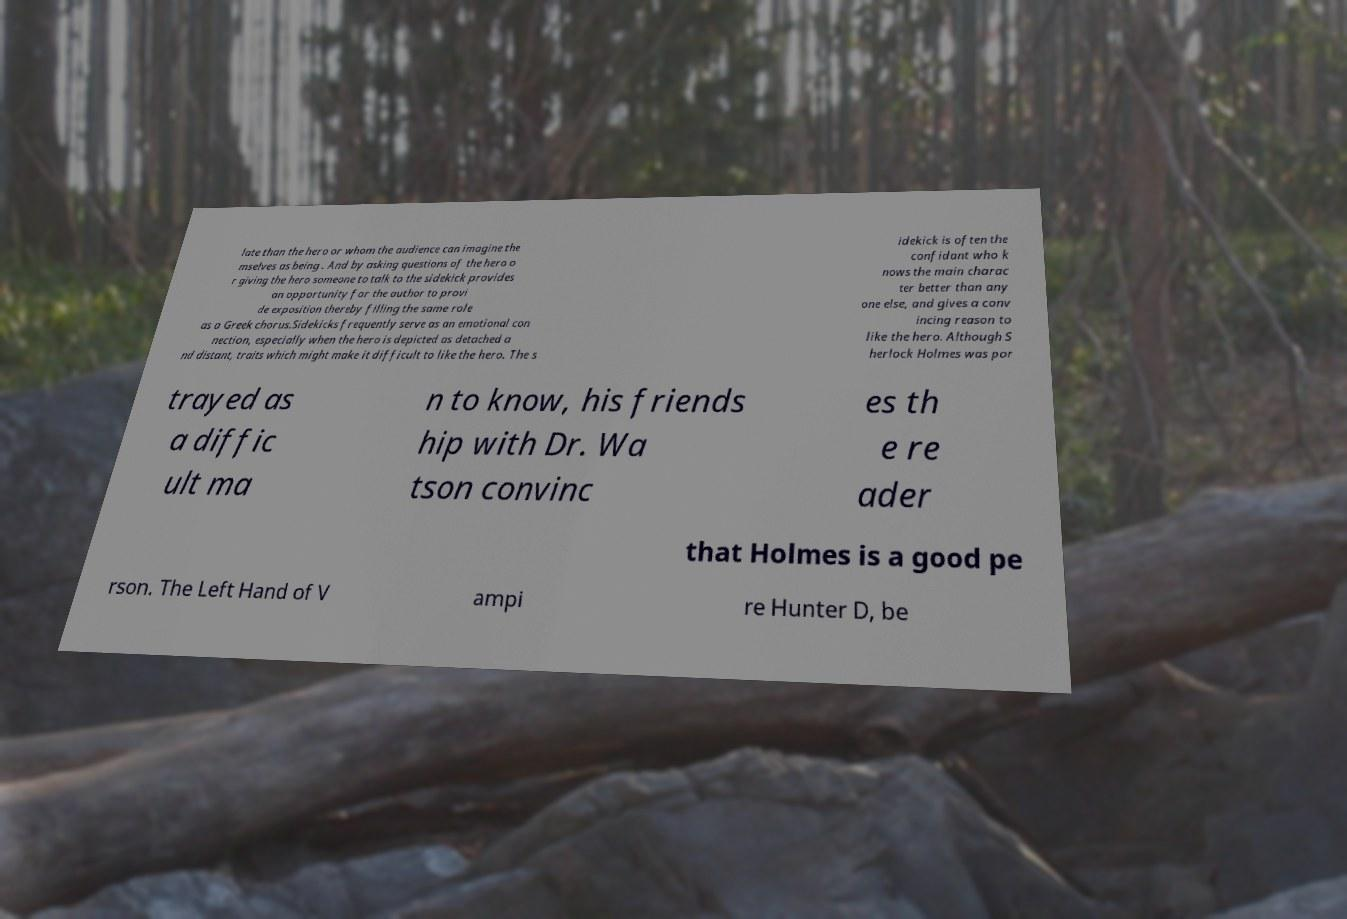For documentation purposes, I need the text within this image transcribed. Could you provide that? late than the hero or whom the audience can imagine the mselves as being . And by asking questions of the hero o r giving the hero someone to talk to the sidekick provides an opportunity for the author to provi de exposition thereby filling the same role as a Greek chorus.Sidekicks frequently serve as an emotional con nection, especially when the hero is depicted as detached a nd distant, traits which might make it difficult to like the hero. The s idekick is often the confidant who k nows the main charac ter better than any one else, and gives a conv incing reason to like the hero. Although S herlock Holmes was por trayed as a diffic ult ma n to know, his friends hip with Dr. Wa tson convinc es th e re ader that Holmes is a good pe rson. The Left Hand of V ampi re Hunter D, be 